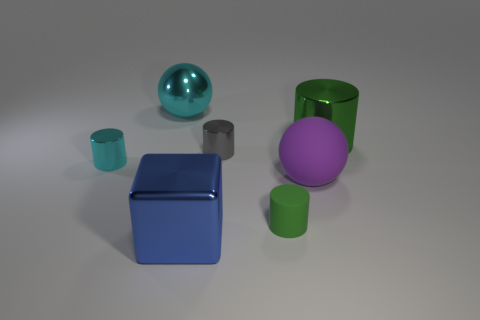Subtract all green cylinders. How many were subtracted if there are1green cylinders left? 1 Subtract all gray cylinders. How many cylinders are left? 3 Subtract all yellow cylinders. Subtract all green balls. How many cylinders are left? 4 Add 1 tiny green rubber things. How many objects exist? 8 Subtract all balls. How many objects are left? 5 Add 5 big cyan objects. How many big cyan objects are left? 6 Add 5 large cyan spheres. How many large cyan spheres exist? 6 Subtract 0 green cubes. How many objects are left? 7 Subtract all small yellow objects. Subtract all cyan spheres. How many objects are left? 6 